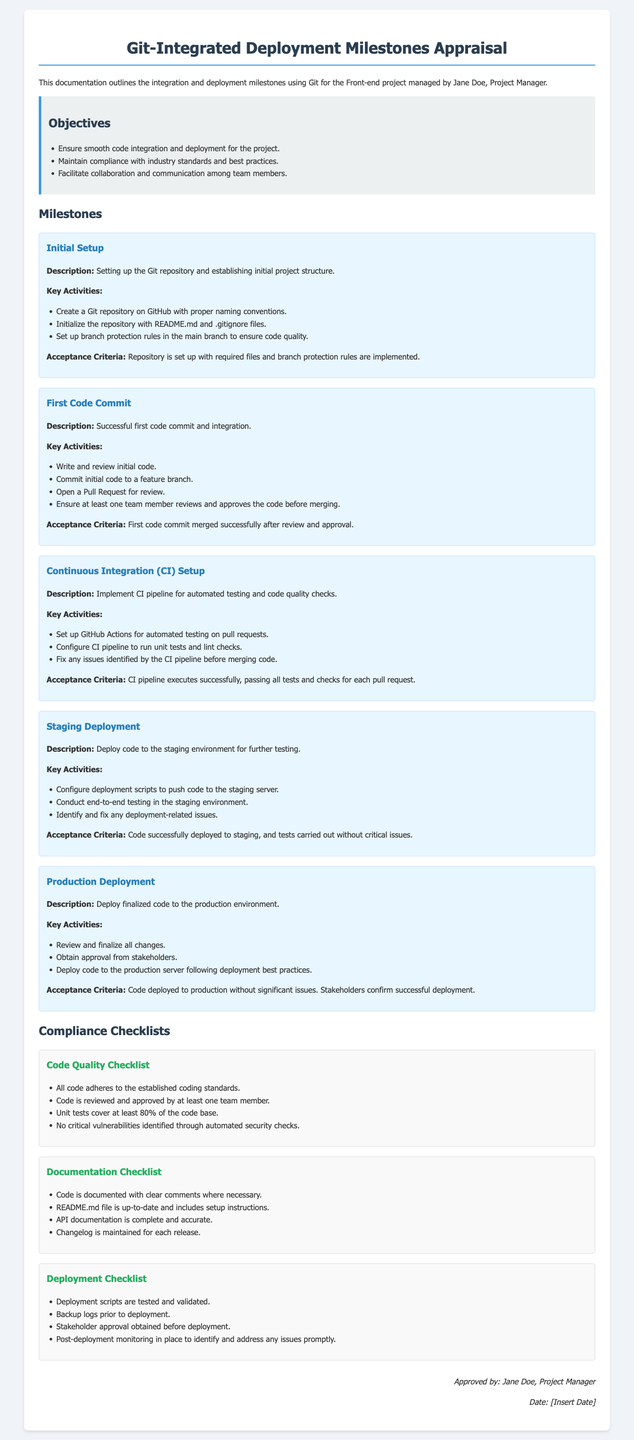What are the objectives listed in the document? The objectives are outlined to ensure smooth code integration, maintain compliance, and facilitate collaboration.
Answer: Ensure smooth code integration and deployment for the project, Maintain compliance with industry standards and best practices, Facilitate collaboration and communication among team members Who is the project manager mentioned in the document? The project manager is identified at the beginning, who oversees the Front-end project.
Answer: Jane Doe What is the acceptance criteria for the Initial Setup milestone? This criteria outlines what must be achieved for the milestone to be considered complete.
Answer: Repository is set up with required files and branch protection rules are implemented How many key activities are there for the First Code Commit milestone? The count of the activities listed for that particular milestone is sought.
Answer: Four What checks are included in the Code Quality Checklist? These checks are standards the code must meet before it can be deemed acceptable.
Answer: All code adheres to the established coding standards, Code is reviewed and approved by at least one team member, Unit tests cover at least 80% of the code base, No critical vulnerabilities identified through automated security checks What does the Documentation Checklist specify about the README.md file? This specifies a requirement for maintaining documentation in the project.
Answer: README.md file is up-to-date and includes setup instructions What is the main goal of the Continuous Integration (CI) Setup milestone? The goal revolves around automation in testing and code quality and serves as a crucial part of the development process.
Answer: Implement CI pipeline for automated testing and code quality checks What is the final step mentioned for the Production Deployment milestone? This is the concluding aspect of deploying code into the production environment.
Answer: Stakeholders confirm successful deployment 